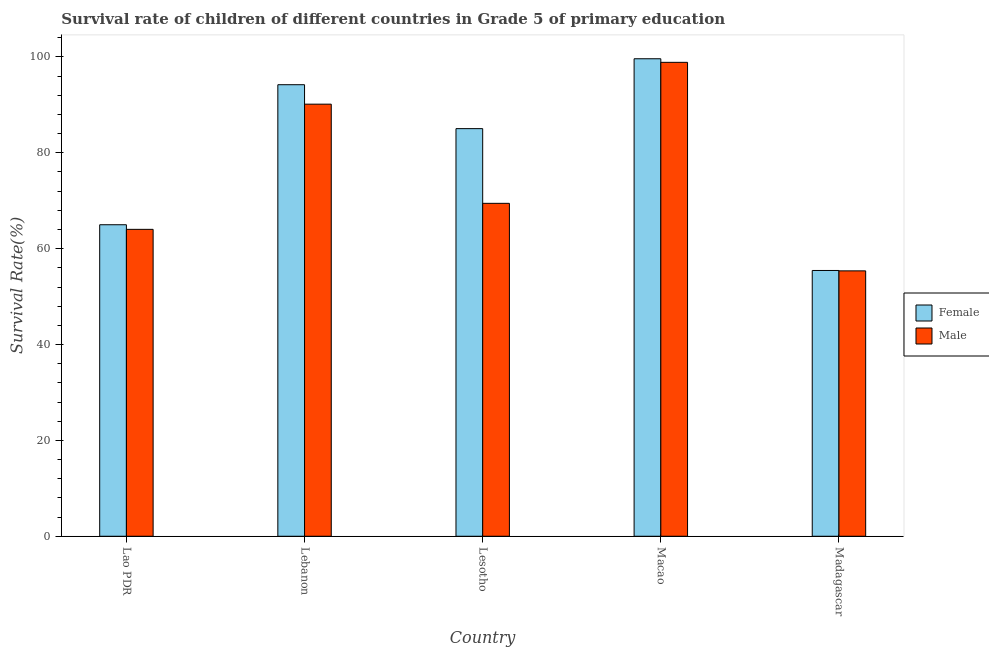Are the number of bars per tick equal to the number of legend labels?
Ensure brevity in your answer.  Yes. How many bars are there on the 5th tick from the left?
Your answer should be very brief. 2. How many bars are there on the 2nd tick from the right?
Offer a terse response. 2. What is the label of the 4th group of bars from the left?
Give a very brief answer. Macao. In how many cases, is the number of bars for a given country not equal to the number of legend labels?
Give a very brief answer. 0. What is the survival rate of male students in primary education in Lebanon?
Offer a very short reply. 90.15. Across all countries, what is the maximum survival rate of female students in primary education?
Give a very brief answer. 99.62. Across all countries, what is the minimum survival rate of male students in primary education?
Offer a terse response. 55.37. In which country was the survival rate of male students in primary education maximum?
Offer a terse response. Macao. In which country was the survival rate of male students in primary education minimum?
Your answer should be very brief. Madagascar. What is the total survival rate of male students in primary education in the graph?
Offer a terse response. 377.88. What is the difference between the survival rate of female students in primary education in Lao PDR and that in Lesotho?
Provide a succinct answer. -20.05. What is the difference between the survival rate of female students in primary education in Lesotho and the survival rate of male students in primary education in Lebanon?
Provide a short and direct response. -5.1. What is the average survival rate of female students in primary education per country?
Offer a very short reply. 79.86. What is the difference between the survival rate of female students in primary education and survival rate of male students in primary education in Lao PDR?
Your response must be concise. 0.96. What is the ratio of the survival rate of female students in primary education in Lao PDR to that in Madagascar?
Your response must be concise. 1.17. Is the difference between the survival rate of female students in primary education in Lesotho and Madagascar greater than the difference between the survival rate of male students in primary education in Lesotho and Madagascar?
Keep it short and to the point. Yes. What is the difference between the highest and the second highest survival rate of female students in primary education?
Provide a succinct answer. 5.42. What is the difference between the highest and the lowest survival rate of female students in primary education?
Give a very brief answer. 44.17. What does the 2nd bar from the left in Lesotho represents?
Your response must be concise. Male. How many bars are there?
Your answer should be compact. 10. Are all the bars in the graph horizontal?
Keep it short and to the point. No. How many countries are there in the graph?
Provide a short and direct response. 5. Where does the legend appear in the graph?
Your answer should be compact. Center right. How are the legend labels stacked?
Make the answer very short. Vertical. What is the title of the graph?
Your response must be concise. Survival rate of children of different countries in Grade 5 of primary education. What is the label or title of the Y-axis?
Your answer should be compact. Survival Rate(%). What is the Survival Rate(%) in Female in Lao PDR?
Your response must be concise. 64.99. What is the Survival Rate(%) of Male in Lao PDR?
Your answer should be compact. 64.03. What is the Survival Rate(%) in Female in Lebanon?
Keep it short and to the point. 94.21. What is the Survival Rate(%) of Male in Lebanon?
Give a very brief answer. 90.15. What is the Survival Rate(%) of Female in Lesotho?
Your answer should be very brief. 85.04. What is the Survival Rate(%) of Male in Lesotho?
Keep it short and to the point. 69.46. What is the Survival Rate(%) of Female in Macao?
Keep it short and to the point. 99.62. What is the Survival Rate(%) in Male in Macao?
Your answer should be compact. 98.87. What is the Survival Rate(%) in Female in Madagascar?
Provide a short and direct response. 55.45. What is the Survival Rate(%) in Male in Madagascar?
Provide a succinct answer. 55.37. Across all countries, what is the maximum Survival Rate(%) of Female?
Offer a terse response. 99.62. Across all countries, what is the maximum Survival Rate(%) in Male?
Ensure brevity in your answer.  98.87. Across all countries, what is the minimum Survival Rate(%) of Female?
Provide a succinct answer. 55.45. Across all countries, what is the minimum Survival Rate(%) of Male?
Your response must be concise. 55.37. What is the total Survival Rate(%) in Female in the graph?
Keep it short and to the point. 399.31. What is the total Survival Rate(%) in Male in the graph?
Provide a succinct answer. 377.88. What is the difference between the Survival Rate(%) of Female in Lao PDR and that in Lebanon?
Your answer should be compact. -29.21. What is the difference between the Survival Rate(%) of Male in Lao PDR and that in Lebanon?
Ensure brevity in your answer.  -26.12. What is the difference between the Survival Rate(%) in Female in Lao PDR and that in Lesotho?
Your answer should be compact. -20.05. What is the difference between the Survival Rate(%) of Male in Lao PDR and that in Lesotho?
Offer a terse response. -5.43. What is the difference between the Survival Rate(%) in Female in Lao PDR and that in Macao?
Ensure brevity in your answer.  -34.63. What is the difference between the Survival Rate(%) of Male in Lao PDR and that in Macao?
Make the answer very short. -34.85. What is the difference between the Survival Rate(%) in Female in Lao PDR and that in Madagascar?
Give a very brief answer. 9.54. What is the difference between the Survival Rate(%) of Male in Lao PDR and that in Madagascar?
Your answer should be compact. 8.66. What is the difference between the Survival Rate(%) of Female in Lebanon and that in Lesotho?
Provide a succinct answer. 9.16. What is the difference between the Survival Rate(%) of Male in Lebanon and that in Lesotho?
Offer a terse response. 20.69. What is the difference between the Survival Rate(%) in Female in Lebanon and that in Macao?
Your response must be concise. -5.42. What is the difference between the Survival Rate(%) in Male in Lebanon and that in Macao?
Give a very brief answer. -8.73. What is the difference between the Survival Rate(%) of Female in Lebanon and that in Madagascar?
Your response must be concise. 38.76. What is the difference between the Survival Rate(%) of Male in Lebanon and that in Madagascar?
Your answer should be very brief. 34.78. What is the difference between the Survival Rate(%) of Female in Lesotho and that in Macao?
Provide a short and direct response. -14.58. What is the difference between the Survival Rate(%) of Male in Lesotho and that in Macao?
Keep it short and to the point. -29.42. What is the difference between the Survival Rate(%) of Female in Lesotho and that in Madagascar?
Offer a terse response. 29.6. What is the difference between the Survival Rate(%) of Male in Lesotho and that in Madagascar?
Your answer should be compact. 14.09. What is the difference between the Survival Rate(%) of Female in Macao and that in Madagascar?
Provide a short and direct response. 44.17. What is the difference between the Survival Rate(%) of Male in Macao and that in Madagascar?
Your answer should be very brief. 43.51. What is the difference between the Survival Rate(%) in Female in Lao PDR and the Survival Rate(%) in Male in Lebanon?
Offer a very short reply. -25.16. What is the difference between the Survival Rate(%) of Female in Lao PDR and the Survival Rate(%) of Male in Lesotho?
Offer a terse response. -4.47. What is the difference between the Survival Rate(%) of Female in Lao PDR and the Survival Rate(%) of Male in Macao?
Offer a terse response. -33.88. What is the difference between the Survival Rate(%) of Female in Lao PDR and the Survival Rate(%) of Male in Madagascar?
Your response must be concise. 9.62. What is the difference between the Survival Rate(%) of Female in Lebanon and the Survival Rate(%) of Male in Lesotho?
Your response must be concise. 24.75. What is the difference between the Survival Rate(%) in Female in Lebanon and the Survival Rate(%) in Male in Macao?
Your response must be concise. -4.67. What is the difference between the Survival Rate(%) in Female in Lebanon and the Survival Rate(%) in Male in Madagascar?
Make the answer very short. 38.84. What is the difference between the Survival Rate(%) of Female in Lesotho and the Survival Rate(%) of Male in Macao?
Your answer should be compact. -13.83. What is the difference between the Survival Rate(%) in Female in Lesotho and the Survival Rate(%) in Male in Madagascar?
Offer a very short reply. 29.68. What is the difference between the Survival Rate(%) of Female in Macao and the Survival Rate(%) of Male in Madagascar?
Your answer should be very brief. 44.26. What is the average Survival Rate(%) in Female per country?
Make the answer very short. 79.86. What is the average Survival Rate(%) in Male per country?
Ensure brevity in your answer.  75.58. What is the difference between the Survival Rate(%) in Female and Survival Rate(%) in Male in Lao PDR?
Provide a short and direct response. 0.96. What is the difference between the Survival Rate(%) in Female and Survival Rate(%) in Male in Lebanon?
Make the answer very short. 4.06. What is the difference between the Survival Rate(%) in Female and Survival Rate(%) in Male in Lesotho?
Provide a succinct answer. 15.59. What is the difference between the Survival Rate(%) in Female and Survival Rate(%) in Male in Macao?
Your answer should be compact. 0.75. What is the difference between the Survival Rate(%) in Female and Survival Rate(%) in Male in Madagascar?
Provide a succinct answer. 0.08. What is the ratio of the Survival Rate(%) in Female in Lao PDR to that in Lebanon?
Provide a short and direct response. 0.69. What is the ratio of the Survival Rate(%) in Male in Lao PDR to that in Lebanon?
Offer a terse response. 0.71. What is the ratio of the Survival Rate(%) of Female in Lao PDR to that in Lesotho?
Offer a very short reply. 0.76. What is the ratio of the Survival Rate(%) of Male in Lao PDR to that in Lesotho?
Your response must be concise. 0.92. What is the ratio of the Survival Rate(%) of Female in Lao PDR to that in Macao?
Ensure brevity in your answer.  0.65. What is the ratio of the Survival Rate(%) of Male in Lao PDR to that in Macao?
Make the answer very short. 0.65. What is the ratio of the Survival Rate(%) of Female in Lao PDR to that in Madagascar?
Ensure brevity in your answer.  1.17. What is the ratio of the Survival Rate(%) in Male in Lao PDR to that in Madagascar?
Keep it short and to the point. 1.16. What is the ratio of the Survival Rate(%) of Female in Lebanon to that in Lesotho?
Offer a very short reply. 1.11. What is the ratio of the Survival Rate(%) in Male in Lebanon to that in Lesotho?
Your answer should be very brief. 1.3. What is the ratio of the Survival Rate(%) in Female in Lebanon to that in Macao?
Your answer should be compact. 0.95. What is the ratio of the Survival Rate(%) in Male in Lebanon to that in Macao?
Give a very brief answer. 0.91. What is the ratio of the Survival Rate(%) of Female in Lebanon to that in Madagascar?
Make the answer very short. 1.7. What is the ratio of the Survival Rate(%) of Male in Lebanon to that in Madagascar?
Keep it short and to the point. 1.63. What is the ratio of the Survival Rate(%) in Female in Lesotho to that in Macao?
Your response must be concise. 0.85. What is the ratio of the Survival Rate(%) in Male in Lesotho to that in Macao?
Your answer should be very brief. 0.7. What is the ratio of the Survival Rate(%) in Female in Lesotho to that in Madagascar?
Provide a short and direct response. 1.53. What is the ratio of the Survival Rate(%) in Male in Lesotho to that in Madagascar?
Keep it short and to the point. 1.25. What is the ratio of the Survival Rate(%) of Female in Macao to that in Madagascar?
Offer a very short reply. 1.8. What is the ratio of the Survival Rate(%) in Male in Macao to that in Madagascar?
Make the answer very short. 1.79. What is the difference between the highest and the second highest Survival Rate(%) in Female?
Offer a very short reply. 5.42. What is the difference between the highest and the second highest Survival Rate(%) of Male?
Your answer should be very brief. 8.73. What is the difference between the highest and the lowest Survival Rate(%) in Female?
Your answer should be compact. 44.17. What is the difference between the highest and the lowest Survival Rate(%) of Male?
Your response must be concise. 43.51. 